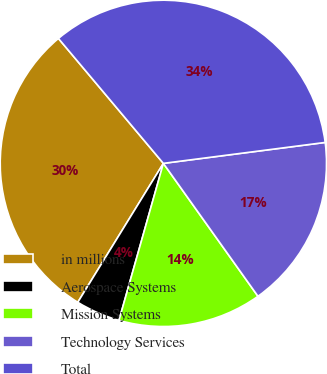Convert chart to OTSL. <chart><loc_0><loc_0><loc_500><loc_500><pie_chart><fcel>in millions<fcel>Aerospace Systems<fcel>Mission Systems<fcel>Technology Services<fcel>Total<nl><fcel>30.09%<fcel>4.4%<fcel>14.23%<fcel>17.2%<fcel>34.07%<nl></chart> 